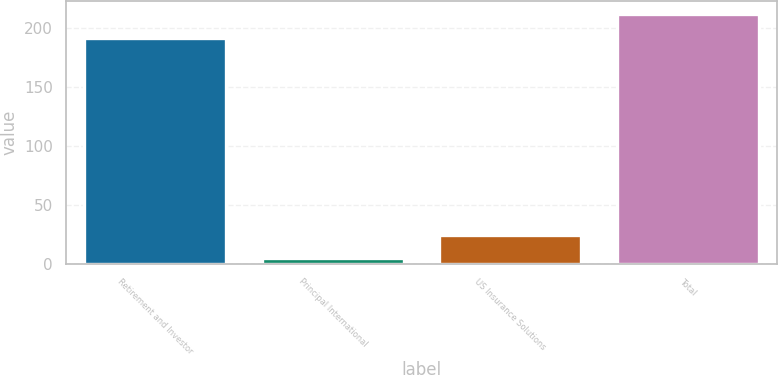Convert chart to OTSL. <chart><loc_0><loc_0><loc_500><loc_500><bar_chart><fcel>Retirement and Investor<fcel>Principal International<fcel>US Insurance Solutions<fcel>Total<nl><fcel>192.2<fcel>4.3<fcel>24.46<fcel>212.36<nl></chart> 